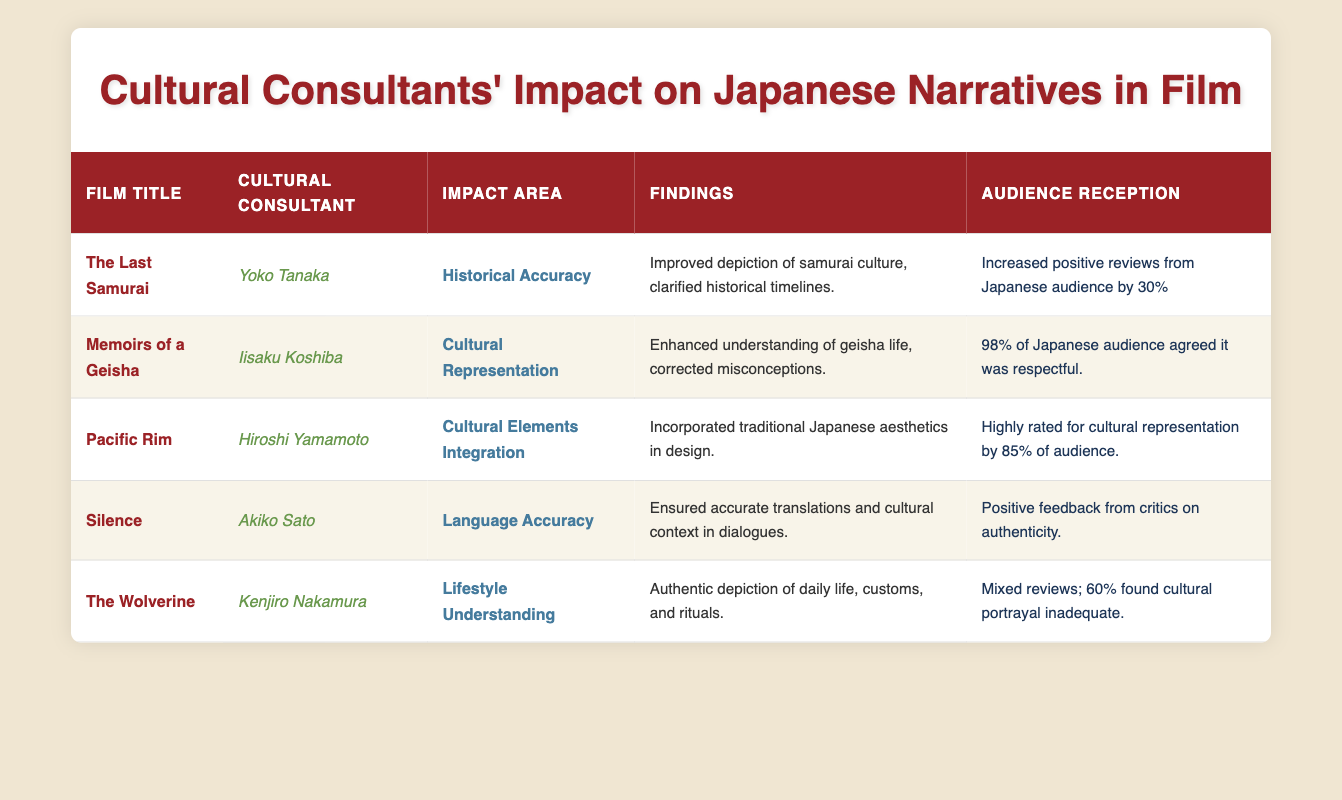What was the impact area for "The Last Samurai"? The impact area for "The Last Samurai" is Historical Accuracy, as indicated in the table.
Answer: Historical Accuracy How many Japanese audience members found "Memoirs of a Geisha" respectful? According to the table, 98% of the Japanese audience agreed that "Memoirs of a Geisha" was respectful.
Answer: 98% Which film had mixed reviews regarding cultural portrayal? The table states that "The Wolverine" received mixed reviews, with 60% finding its cultural portrayal inadequate.
Answer: The Wolverine Which cultural consultant worked on the film "Silence"? The table shows that Akiko Sato was the cultural consultant for the film "Silence."
Answer: Akiko Sato What is the average percentage of positive audience reception across the listed films? To find the average, we first note the positive reception percentages: 30%, 98%, 85%, considering "Silence" as positive, given the feedback, we'll assume a value of 100%, and "The Wolverine," which was 60%. Therefore, the average is (30 + 98 + 85 + 100 + 60) / 5 = 474 / 5 = 94.8%.
Answer: 94.8% Did any of the films have positive reviews from critics on authenticity? Yes, according to the table, "Silence" had positive feedback from critics on authenticity.
Answer: Yes Which film incorporated traditional Japanese aesthetics in design? The table indicates that "Pacific Rim," worked on by Hiroshi Yamamoto, incorporated traditional Japanese aesthetics in its design.
Answer: Pacific Rim Is there a cultural consultant associated with improving lifestyle understanding in Japanese narratives? Yes, Kenjiro Nakamura, the cultural consultant for "The Wolverine," focused on lifestyle understanding.
Answer: Yes What is the significance of Akiko Sato's contribution to "Silence"? Akiko Sato ensured accurate translations and cultural context in dialogues, which contributes to the film's authenticity, as noted in the findings.
Answer: Accurate translations and cultural context 